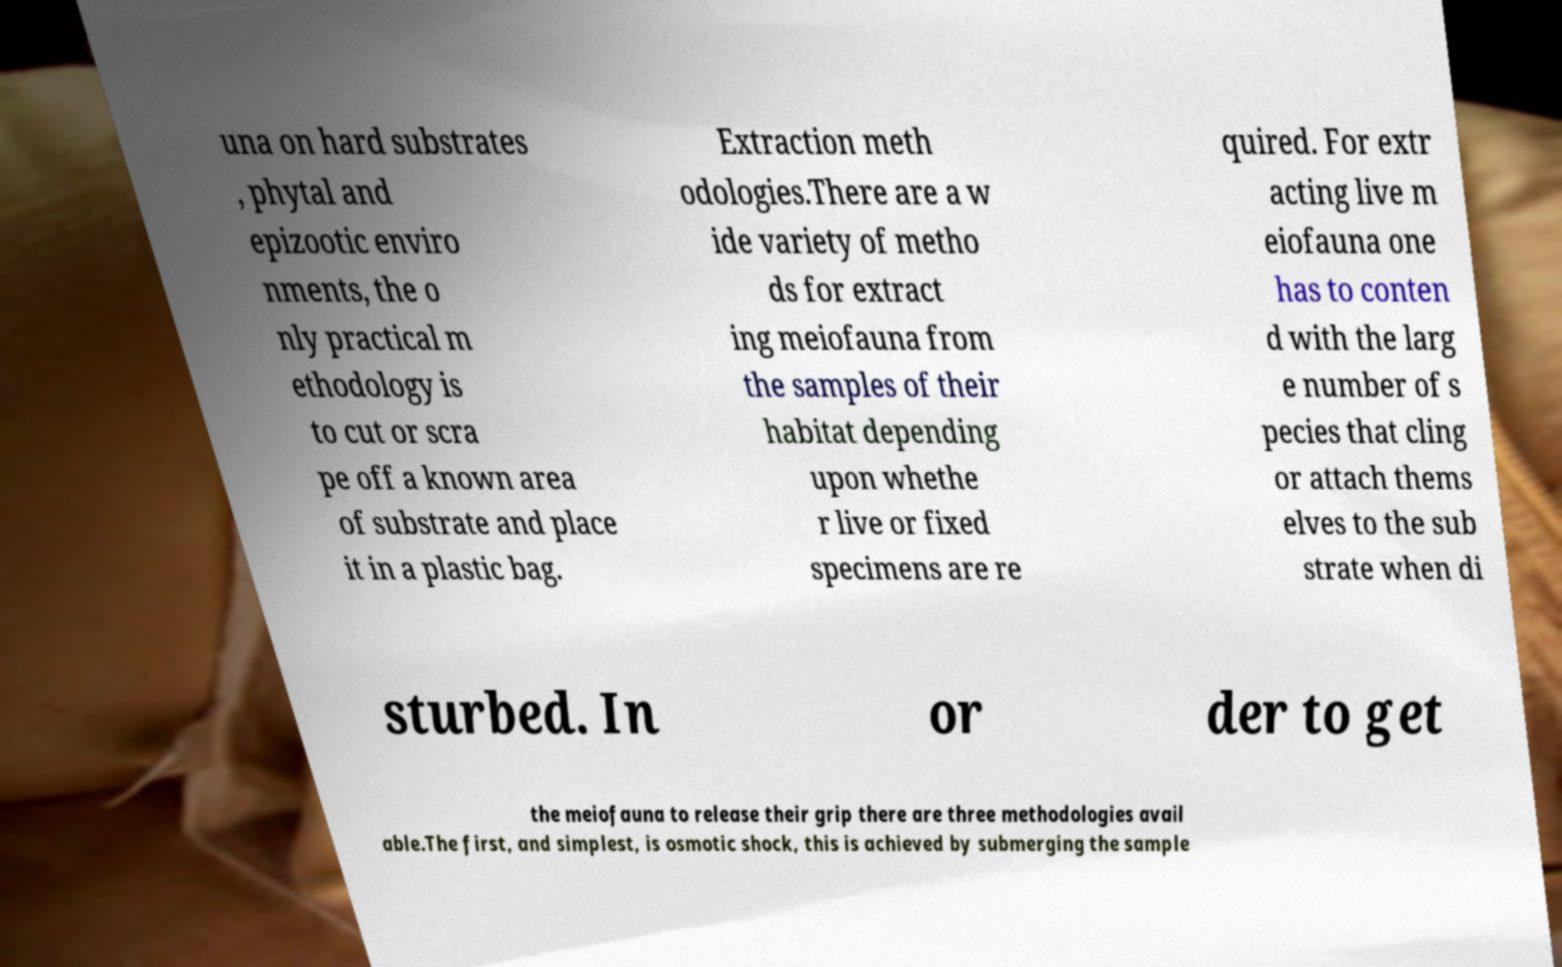What messages or text are displayed in this image? I need them in a readable, typed format. una on hard substrates , phytal and epizootic enviro nments, the o nly practical m ethodology is to cut or scra pe off a known area of substrate and place it in a plastic bag. Extraction meth odologies.There are a w ide variety of metho ds for extract ing meiofauna from the samples of their habitat depending upon whethe r live or fixed specimens are re quired. For extr acting live m eiofauna one has to conten d with the larg e number of s pecies that cling or attach thems elves to the sub strate when di sturbed. In or der to get the meiofauna to release their grip there are three methodologies avail able.The first, and simplest, is osmotic shock, this is achieved by submerging the sample 